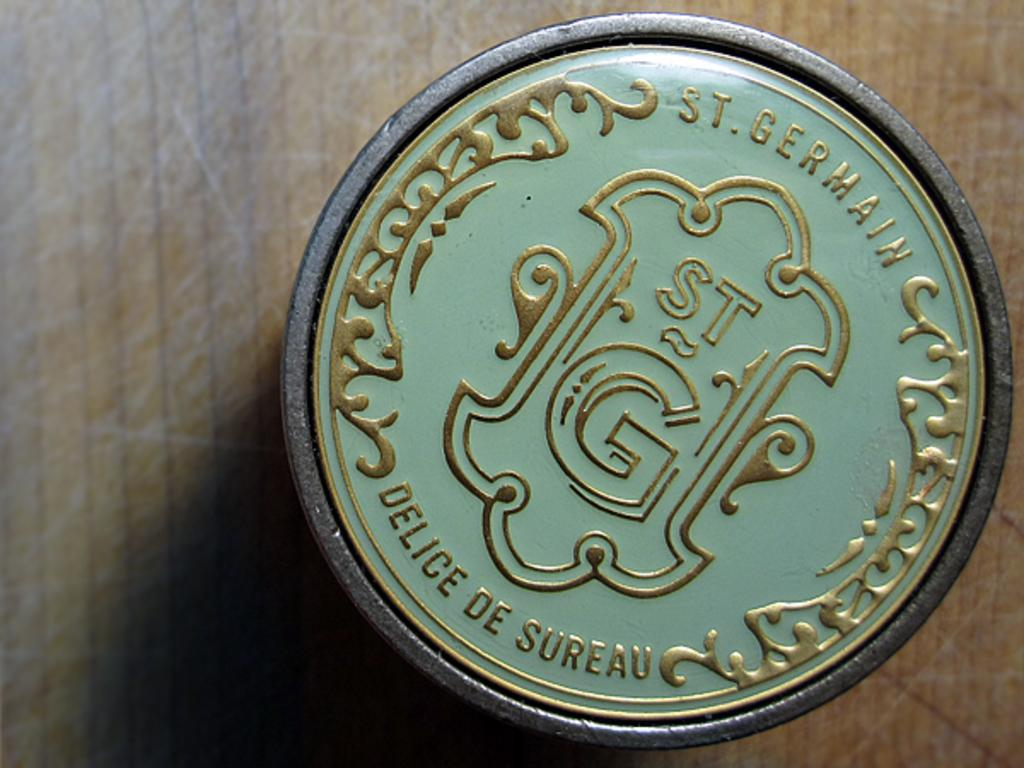<image>
Give a short and clear explanation of the subsequent image. A green top for St. Germain with gold lettering and a design in the middle. 